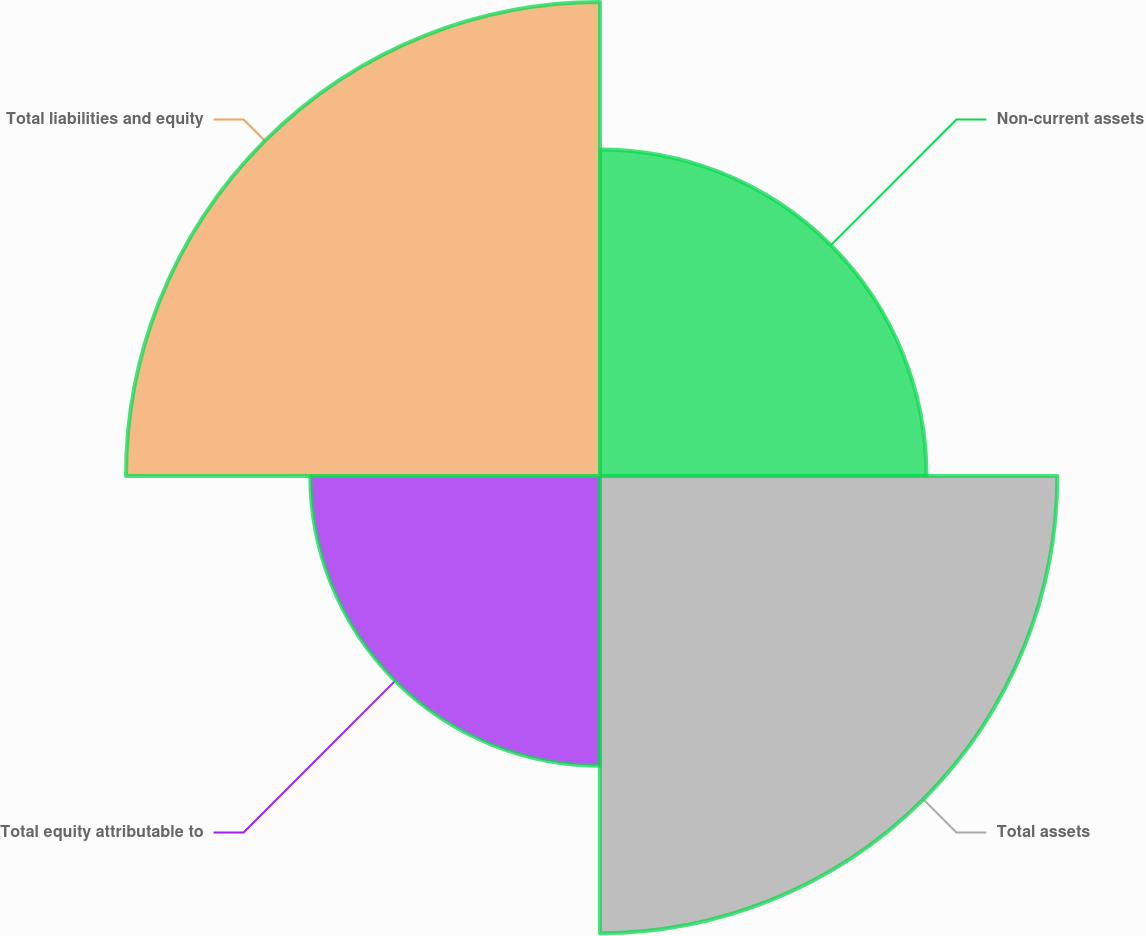Convert chart. <chart><loc_0><loc_0><loc_500><loc_500><pie_chart><fcel>Non-current assets<fcel>Total assets<fcel>Total equity attributable to<fcel>Total liabilities and equity<nl><fcel>21.1%<fcel>29.55%<fcel>18.72%<fcel>30.63%<nl></chart> 